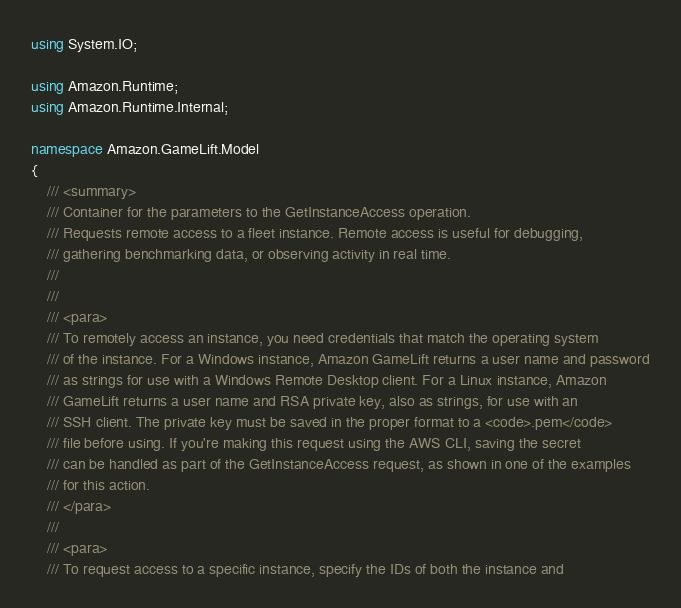<code> <loc_0><loc_0><loc_500><loc_500><_C#_>using System.IO;

using Amazon.Runtime;
using Amazon.Runtime.Internal;

namespace Amazon.GameLift.Model
{
    /// <summary>
    /// Container for the parameters to the GetInstanceAccess operation.
    /// Requests remote access to a fleet instance. Remote access is useful for debugging,
    /// gathering benchmarking data, or observing activity in real time. 
    /// 
    ///  
    /// <para>
    /// To remotely access an instance, you need credentials that match the operating system
    /// of the instance. For a Windows instance, Amazon GameLift returns a user name and password
    /// as strings for use with a Windows Remote Desktop client. For a Linux instance, Amazon
    /// GameLift returns a user name and RSA private key, also as strings, for use with an
    /// SSH client. The private key must be saved in the proper format to a <code>.pem</code>
    /// file before using. If you're making this request using the AWS CLI, saving the secret
    /// can be handled as part of the GetInstanceAccess request, as shown in one of the examples
    /// for this action. 
    /// </para>
    ///  
    /// <para>
    /// To request access to a specific instance, specify the IDs of both the instance and</code> 